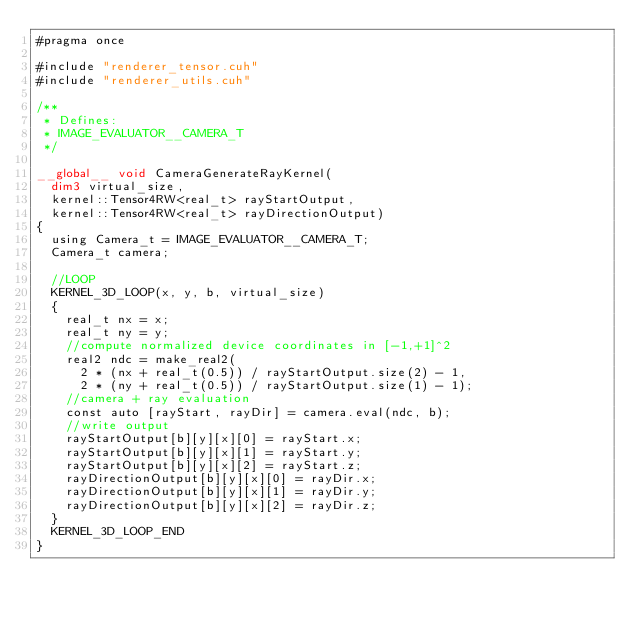<code> <loc_0><loc_0><loc_500><loc_500><_Cuda_>#pragma once

#include "renderer_tensor.cuh"
#include "renderer_utils.cuh"

/**
 * Defines:
 * IMAGE_EVALUATOR__CAMERA_T
 */

__global__ void CameraGenerateRayKernel(
	dim3 virtual_size, 
	kernel::Tensor4RW<real_t> rayStartOutput,
	kernel::Tensor4RW<real_t> rayDirectionOutput)
{
	using Camera_t = IMAGE_EVALUATOR__CAMERA_T;
	Camera_t camera;

	//LOOP
	KERNEL_3D_LOOP(x, y, b, virtual_size)
	{
		real_t nx = x;
		real_t ny = y;
		//compute normalized device coordinates in [-1,+1]^2
		real2 ndc = make_real2(
			2 * (nx + real_t(0.5)) / rayStartOutput.size(2) - 1,
			2 * (ny + real_t(0.5)) / rayStartOutput.size(1) - 1);
		//camera + ray evaluation
		const auto [rayStart, rayDir] = camera.eval(ndc, b);
		//write output
		rayStartOutput[b][y][x][0] = rayStart.x;
		rayStartOutput[b][y][x][1] = rayStart.y;
		rayStartOutput[b][y][x][2] = rayStart.z;
		rayDirectionOutput[b][y][x][0] = rayDir.x;
		rayDirectionOutput[b][y][x][1] = rayDir.y;
		rayDirectionOutput[b][y][x][2] = rayDir.z;
	}
	KERNEL_3D_LOOP_END
}
</code> 